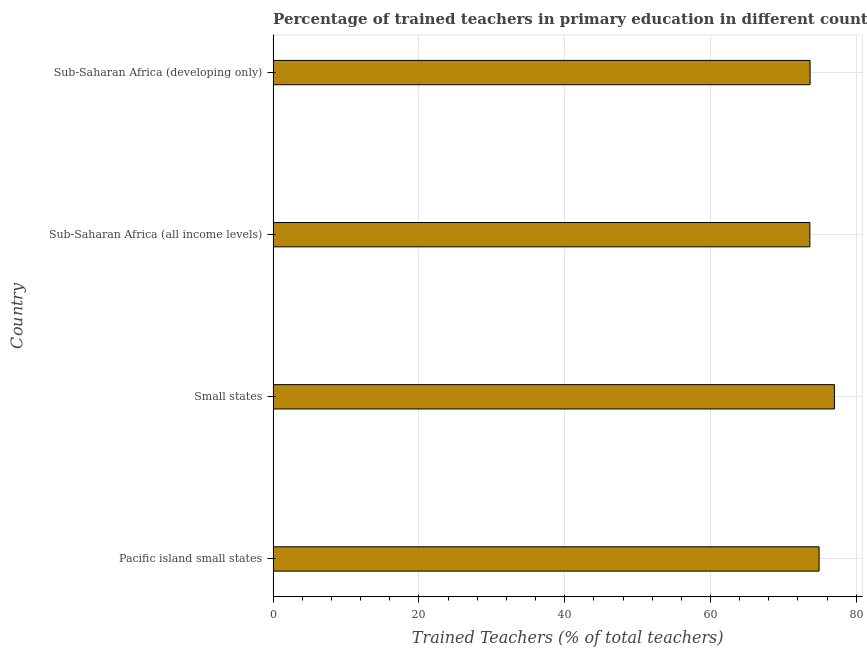Does the graph contain any zero values?
Your answer should be compact. No. Does the graph contain grids?
Make the answer very short. Yes. What is the title of the graph?
Offer a terse response. Percentage of trained teachers in primary education in different countries. What is the label or title of the X-axis?
Offer a very short reply. Trained Teachers (% of total teachers). What is the label or title of the Y-axis?
Provide a short and direct response. Country. What is the percentage of trained teachers in Small states?
Your answer should be compact. 77. Across all countries, what is the maximum percentage of trained teachers?
Your response must be concise. 77. Across all countries, what is the minimum percentage of trained teachers?
Offer a very short reply. 73.63. In which country was the percentage of trained teachers maximum?
Ensure brevity in your answer.  Small states. In which country was the percentage of trained teachers minimum?
Give a very brief answer. Sub-Saharan Africa (all income levels). What is the sum of the percentage of trained teachers?
Make the answer very short. 299.18. What is the difference between the percentage of trained teachers in Pacific island small states and Sub-Saharan Africa (all income levels)?
Your answer should be very brief. 1.27. What is the average percentage of trained teachers per country?
Ensure brevity in your answer.  74.8. What is the median percentage of trained teachers?
Ensure brevity in your answer.  74.28. Is the difference between the percentage of trained teachers in Sub-Saharan Africa (all income levels) and Sub-Saharan Africa (developing only) greater than the difference between any two countries?
Your response must be concise. No. What is the difference between the highest and the second highest percentage of trained teachers?
Provide a succinct answer. 2.1. What is the difference between the highest and the lowest percentage of trained teachers?
Ensure brevity in your answer.  3.37. How many bars are there?
Offer a terse response. 4. How many countries are there in the graph?
Your answer should be compact. 4. What is the difference between two consecutive major ticks on the X-axis?
Offer a very short reply. 20. What is the Trained Teachers (% of total teachers) of Pacific island small states?
Give a very brief answer. 74.9. What is the Trained Teachers (% of total teachers) of Small states?
Provide a short and direct response. 77. What is the Trained Teachers (% of total teachers) in Sub-Saharan Africa (all income levels)?
Make the answer very short. 73.63. What is the Trained Teachers (% of total teachers) of Sub-Saharan Africa (developing only)?
Provide a short and direct response. 73.66. What is the difference between the Trained Teachers (% of total teachers) in Pacific island small states and Small states?
Provide a succinct answer. -2.1. What is the difference between the Trained Teachers (% of total teachers) in Pacific island small states and Sub-Saharan Africa (all income levels)?
Your answer should be very brief. 1.27. What is the difference between the Trained Teachers (% of total teachers) in Pacific island small states and Sub-Saharan Africa (developing only)?
Your answer should be very brief. 1.24. What is the difference between the Trained Teachers (% of total teachers) in Small states and Sub-Saharan Africa (all income levels)?
Keep it short and to the point. 3.37. What is the difference between the Trained Teachers (% of total teachers) in Small states and Sub-Saharan Africa (developing only)?
Provide a succinct answer. 3.34. What is the difference between the Trained Teachers (% of total teachers) in Sub-Saharan Africa (all income levels) and Sub-Saharan Africa (developing only)?
Keep it short and to the point. -0.03. What is the ratio of the Trained Teachers (% of total teachers) in Small states to that in Sub-Saharan Africa (all income levels)?
Your response must be concise. 1.05. What is the ratio of the Trained Teachers (% of total teachers) in Small states to that in Sub-Saharan Africa (developing only)?
Your response must be concise. 1.04. 